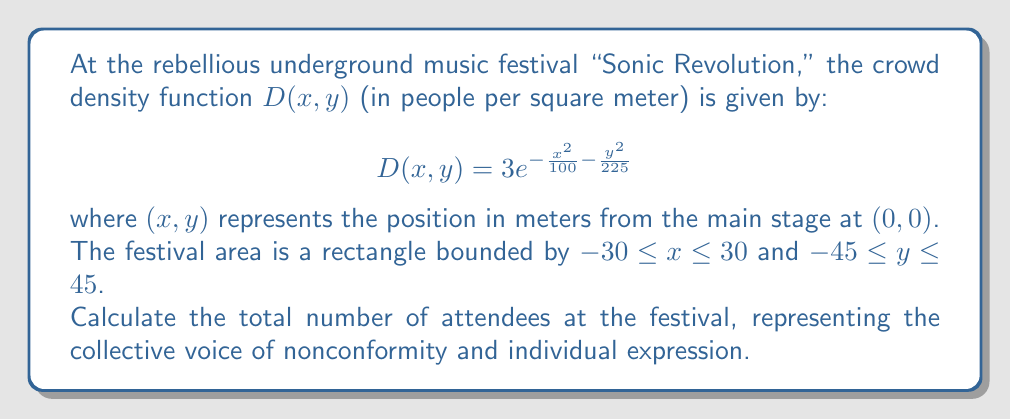Show me your answer to this math problem. To find the total number of attendees, we need to integrate the crowd density function over the entire festival area. This requires a double integral.

1) Set up the double integral:

$$\iint_R D(x,y) \, dA = \int_{-45}^{45} \int_{-30}^{30} 3e^{-\frac{x^2}{100} - \frac{y^2}{225}} \, dx \, dy$$

2) We can evaluate this integral using the following steps:

   a) First, integrate with respect to x:
   
   $$\int_{-30}^{30} 3e^{-\frac{x^2}{100}} \, dx = 3 \sqrt{100\pi} \, \text{erf}\left(\frac{3}{\sqrt{10}}\right)$$
   
   where erf is the error function.

   b) Now our integral becomes:
   
   $$\int_{-45}^{45} 3 \sqrt{100\pi} \, \text{erf}\left(\frac{3}{\sqrt{10}}\right) e^{-\frac{y^2}{225}} \, dy$$

   c) Integrate with respect to y:
   
   $$3 \sqrt{100\pi} \, \text{erf}\left(\frac{3}{\sqrt{10}}\right) \cdot \sqrt{225\pi} \, \text{erf}\left(\frac{3}{\sqrt{15}}\right)$$

3) Simplify:

$$300\pi \cdot \text{erf}\left(\frac{3}{\sqrt{10}}\right) \cdot \text{erf}\left(\frac{3}{\sqrt{15}}\right)$$

4) Calculate the numerical value:

$$300\pi \cdot 0.9661051464753107 \cdot 0.9089094920521542 \approx 828.81$$

Thus, the total number of attendees is approximately 829 people (rounded to the nearest whole number).
Answer: 829 people 